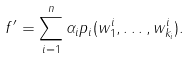Convert formula to latex. <formula><loc_0><loc_0><loc_500><loc_500>f ^ { \prime } = \sum _ { i = 1 } ^ { n } \alpha _ { i } p _ { i } ( w _ { 1 } ^ { i } , \dots , w _ { k _ { i } } ^ { i } ) .</formula> 